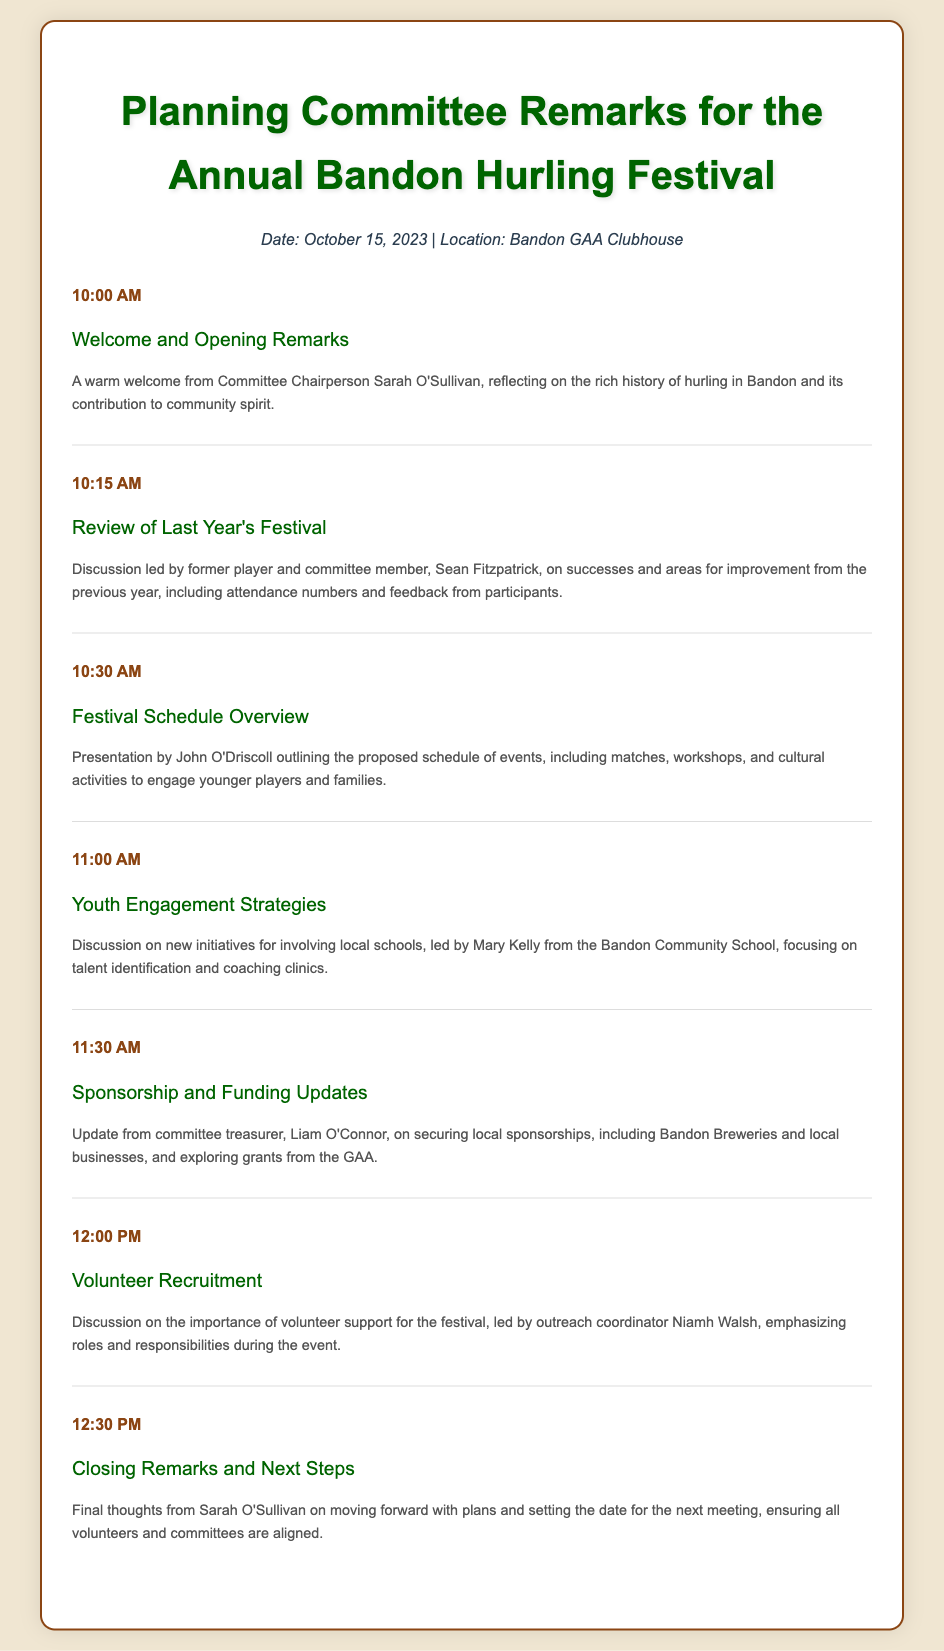What is the date of the annual festival meeting? The date is explicitly stated in the header info of the document.
Answer: October 15, 2023 Who is leading the review of last year's festival? The document specifies that Sean Fitzpatrick is leading this discussion.
Answer: Sean Fitzpatrick What time does the festival schedule overview presentation start? The time is mentioned in the agenda item for the festival schedule overview.
Answer: 10:30 AM What is one of the new initiatives discussed for youth engagement? This information is found in the agenda item outlining the discussion led by Mary Kelly.
Answer: Talent identification Who is providing the sponsorship update? The document states that the committee treasurer, Liam O'Connor, is providing this update.
Answer: Liam O'Connor What is the main topic of the session at 12:00 PM? The document clearly lists the topic for that session.
Answer: Volunteer Recruitment What will Sarah O'Sullivan discuss in the closing remarks? The document indicates that she will talk about moving forward with plans.
Answer: Moving forward with plans 